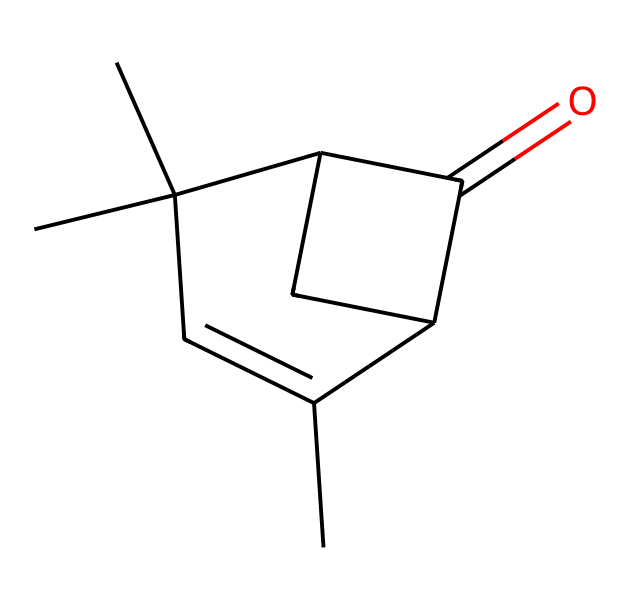What is the molecular formula of pinocamphone? The SMILES representation indicates the presence of carbon (C) and hydrogen (H) atoms. Counting the 'C's and 'H's indicates the molecular formula. Here, there are six carbon atoms and ten hydrogen atoms, resulting in the formula C10H16O.
Answer: C10H16O How many rings are present in the structure of pinocamphone? Upon analyzing the structure, we can observe that there are two cyclic structures present. Each cycle can be traced through carbon connections when visualizing the SMILES notation.
Answer: 2 What functional group is indicated by the presence of the oxygen atom in pinocamphone? The oxygen atom in the structure is part of a carbonyl group (C=O) as indicated by its connection with carbon. This is associated with the ketone functional group found in the molecule.
Answer: ketone Does pinocamphone contain any chiral centers? By examining the structure, we confirm that there is a carbon atom (C) connected to four different groups, indicating a chiral center. This corresponds to one of the carbon atoms in the structure.
Answer: Yes What characteristic aromatic features can be identified in pinocamphone? The structure exhibits a cyclic arrangement of carbon atoms, signifying it embodies aromatic properties, specifically due to the presence of sp2 hybridized carbons that ensure delocalization of electrons.
Answer: Aromatic How does the structure of pinocamphone influence its fragrance profile? The specific arrangement of carbon atoms along with functional groups affects how the molecule interacts with receptor sites in the olfactory system, resulting in a distinct scent profile often characterized as herbal or medicinal.
Answer: Herbal 